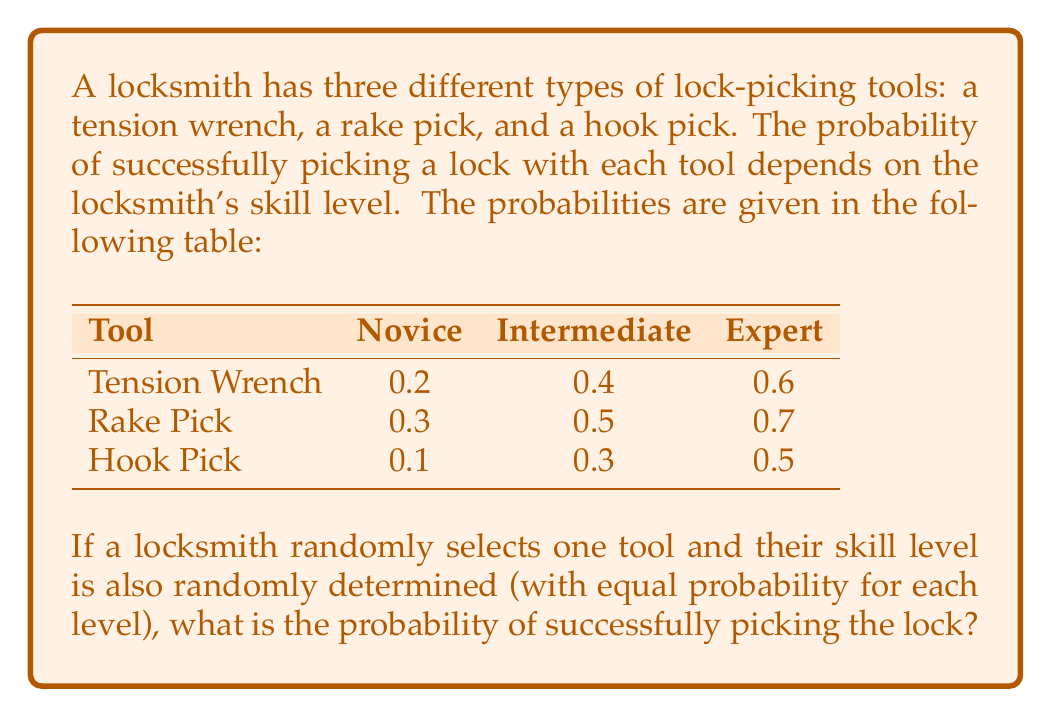What is the answer to this math problem? To solve this problem, we need to use the law of total probability. We'll calculate the probability of success for each combination of tool and skill level, then sum these probabilities.

Let's define the events:
- $T_1$, $T_2$, $T_3$: selecting tension wrench, rake pick, and hook pick respectively
- $S_1$, $S_2$, $S_3$: novice, intermediate, and expert skill levels respectively
- $A$: successfully picking the lock

Step 1: Calculate the probability of selecting each tool and skill level.
$P(T_1) = P(T_2) = P(T_3) = \frac{1}{3}$ (equal probability for each tool)
$P(S_1) = P(S_2) = P(S_3) = \frac{1}{3}$ (equal probability for each skill level)

Step 2: Use the law of total probability:

$$P(A) = \sum_{i=1}^3 \sum_{j=1}^3 P(A|T_i, S_j) \cdot P(T_i) \cdot P(S_j)$$

Step 3: Calculate each term in the sum:

$P(A|T_1, S_1) \cdot P(T_1) \cdot P(S_1) = 0.2 \cdot \frac{1}{3} \cdot \frac{1}{3} = \frac{0.2}{9}$
$P(A|T_1, S_2) \cdot P(T_1) \cdot P(S_2) = 0.4 \cdot \frac{1}{3} \cdot \frac{1}{3} = \frac{0.4}{9}$
$P(A|T_1, S_3) \cdot P(T_1) \cdot P(S_3) = 0.6 \cdot \frac{1}{3} \cdot \frac{1}{3} = \frac{0.6}{9}$
$P(A|T_2, S_1) \cdot P(T_2) \cdot P(S_1) = 0.3 \cdot \frac{1}{3} \cdot \frac{1}{3} = \frac{0.3}{9}$
$P(A|T_2, S_2) \cdot P(T_2) \cdot P(S_2) = 0.5 \cdot \frac{1}{3} \cdot \frac{1}{3} = \frac{0.5}{9}$
$P(A|T_2, S_3) \cdot P(T_2) \cdot P(S_3) = 0.7 \cdot \frac{1}{3} \cdot \frac{1}{3} = \frac{0.7}{9}$
$P(A|T_3, S_1) \cdot P(T_3) \cdot P(S_1) = 0.1 \cdot \frac{1}{3} \cdot \frac{1}{3} = \frac{0.1}{9}$
$P(A|T_3, S_2) \cdot P(T_3) \cdot P(S_2) = 0.3 \cdot \frac{1}{3} \cdot \frac{1}{3} = \frac{0.3}{9}$
$P(A|T_3, S_3) \cdot P(T_3) \cdot P(S_3) = 0.5 \cdot \frac{1}{3} \cdot \frac{1}{3} = \frac{0.5}{9}$

Step 4: Sum all terms:

$$P(A) = \frac{0.2 + 0.4 + 0.6 + 0.3 + 0.5 + 0.7 + 0.1 + 0.3 + 0.5}{9} = \frac{3.6}{9} = 0.4$$
Answer: The probability of successfully picking the lock is 0.4 or 40%. 